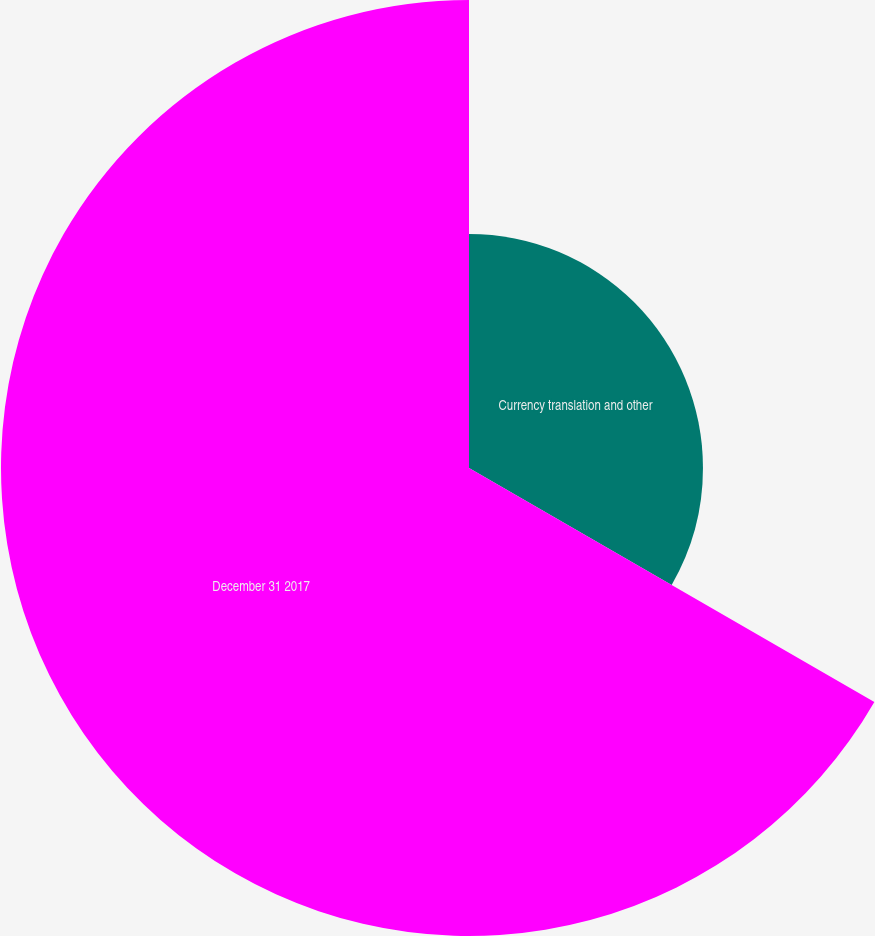Convert chart. <chart><loc_0><loc_0><loc_500><loc_500><pie_chart><fcel>Currency translation and other<fcel>December 31 2017<nl><fcel>33.33%<fcel>66.67%<nl></chart> 